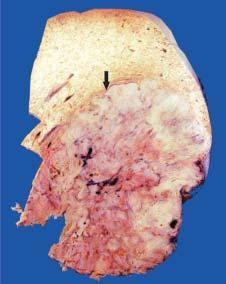what shows many nodules of variable sizes owing to co-existent macronodular cirrhosis?
Answer the question using a single word or phrase. Rest of the hepatic parenchyma in the upper part of the picture 